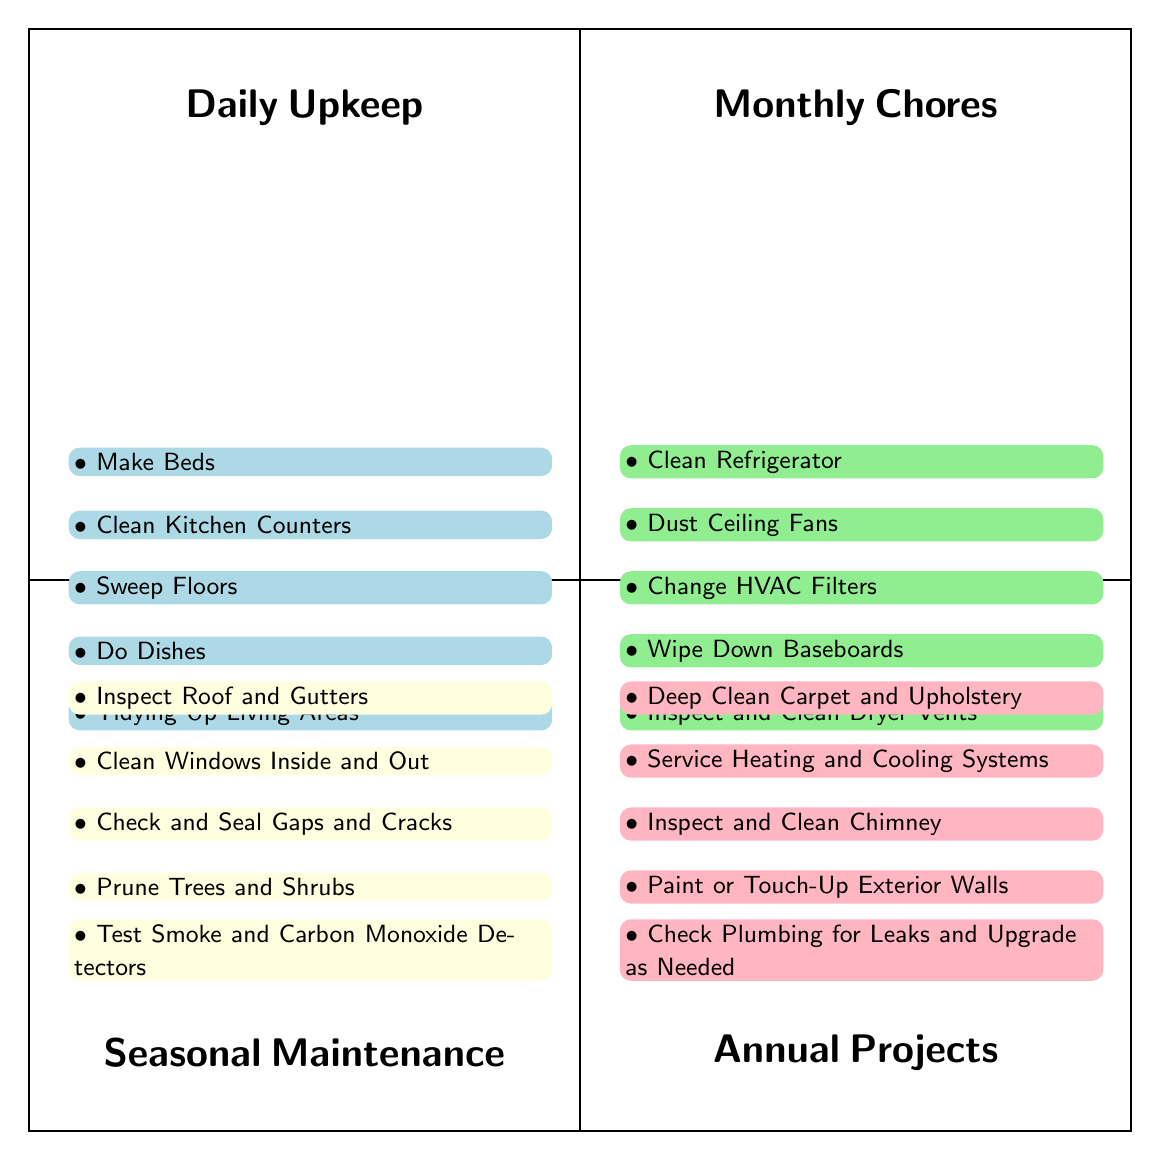What's listed under Daily Upkeep? The diagram highlights the tasks categorized under Daily Upkeep in the top-left quadrant. These tasks are: Make Beds, Clean Kitchen Counters, Sweep Floors, Do Dishes, and Tidying Up Living Areas.
Answer: Make Beds, Clean Kitchen Counters, Sweep Floors, Do Dishes, Tidying Up Living Areas How many tasks are listed in Monthly Chores? In the Monthly Chores quadrant, there are five tasks displayed vertically. Each task corresponds to a bullet point, so counting these gives the total number.
Answer: 5 Which task appears in the Annual Projects category? The Annual Projects quadrant contains five tasks. By examining this quadrant specifically, one can pick any task listed such as Deep Clean Carpet and Upholstery.
Answer: Deep Clean Carpet and Upholstery What is the main difference between Daily Upkeep and Seasonal Maintenance in terms of frequency? Daily Upkeep tasks are performed every day, while Seasonal Maintenance tasks are performed once per season. This distinction highlights their frequency in the maintenance schedule presented in the diagram.
Answer: Frequency Which quadrant contains the task "Inspect Roof and Gutters"? By analyzing the quadrant layout, "Inspect Roof and Gutters" is identified within the Seasonal Maintenance section, which occupies the bottom-left quadrant of the chart.
Answer: Seasonal Maintenance What color represents Monthly Chores in the diagram? The Monthly Chores quadrant is represented by the light green color used for its background. This color distinction helps identify the category visually among others.
Answer: Light green Which quadrant has tasks that typically require the most time to complete? Generally, Annual Projects tend to require more time because they involve more extensive tasks compared to others. This categorization stems from the nature of the tasks—like painting or servicing systems—that usually take longer to complete.
Answer: Annual Projects How many quadrants are represented in the diagram? The diagram is structured into four distinct quadrants: Daily Upkeep, Monthly Chores, Seasonal Maintenance, and Annual Projects, which constitutes the entire layout.
Answer: 4 Which type of maintenance task includes "Check and Seal Gaps and Cracks"? The task "Check and Seal Gaps and Cracks" is included within the Seasonal Maintenance category, as indicated in its specific quadrant placement in the diagram.
Answer: Seasonal Maintenance 